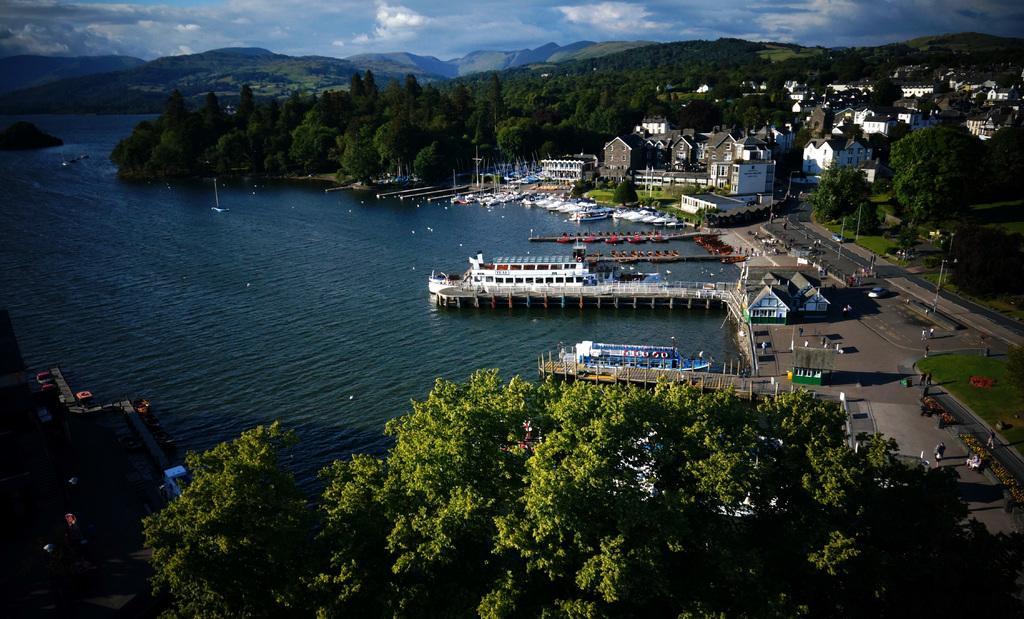In one or two sentences, can you explain what this image depicts? In the picture we can see an Aerial view of the city with river and water in it with boats and trees, plants, houses, buildings, roads and vehicles on it and in the background we can see hills and sky with clouds. 